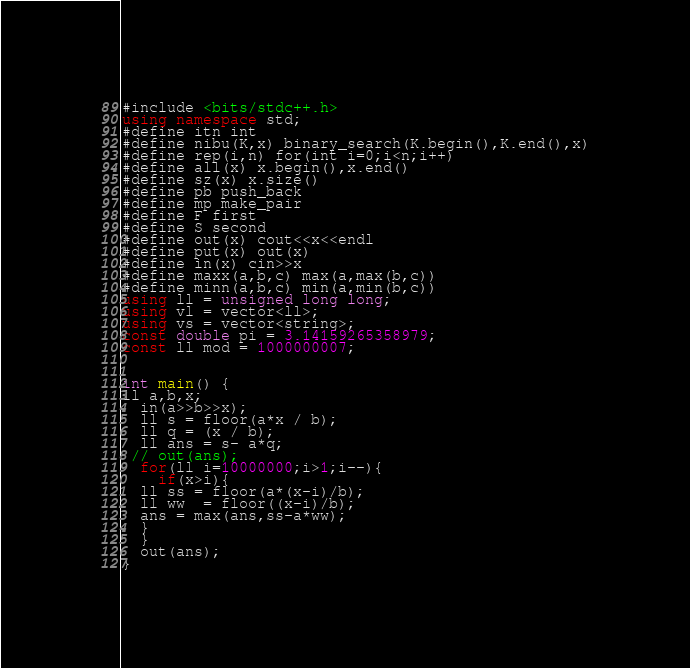<code> <loc_0><loc_0><loc_500><loc_500><_C++_>#include <bits/stdc++.h>
using namespace std;
#define itn int
#define nibu(K,x) binary_search(K.begin(),K.end(),x)
#define rep(i,n) for(int i=0;i<n;i++)
#define all(x) x.begin(),x.end()
#define sz(x) x.size()
#define pb push_back
#define mp make_pair
#define F first
#define S second
#define out(x) cout<<x<<endl
#define put(x) out(x)
#define in(x) cin>>x
#define maxx(a,b,c) max(a,max(b,c))
#define minn(a,b,c) min(a,min(b,c))
using ll = unsigned long long;
using vl = vector<ll>;
using vs = vector<string>;
const double pi = 3.14159265358979;
const ll mod = 1000000007;


int main() {
ll a,b,x;
  in(a>>b>>x);
  ll s = floor(a*x / b);
  ll q = (x / b);
  ll ans = s- a*q;
 // out(ans);
  for(ll i=10000000;i>1;i--){
    if(x>i){
  ll ss = floor(a*(x-i)/b);
  ll ww  = floor((x-i)/b);
  ans = max(ans,ss-a*ww);
  }
  }
  out(ans);
}
</code> 